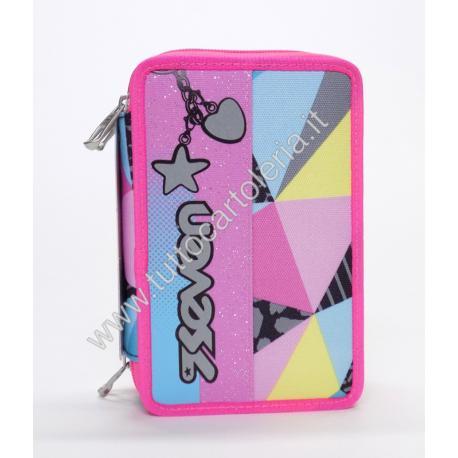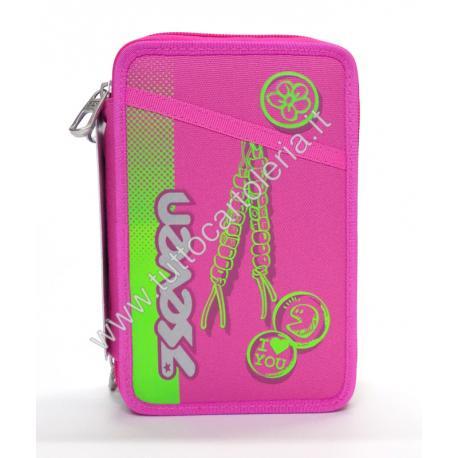The first image is the image on the left, the second image is the image on the right. Assess this claim about the two images: "The brand logo is visible on the outside of both pouches.". Correct or not? Answer yes or no. Yes. 